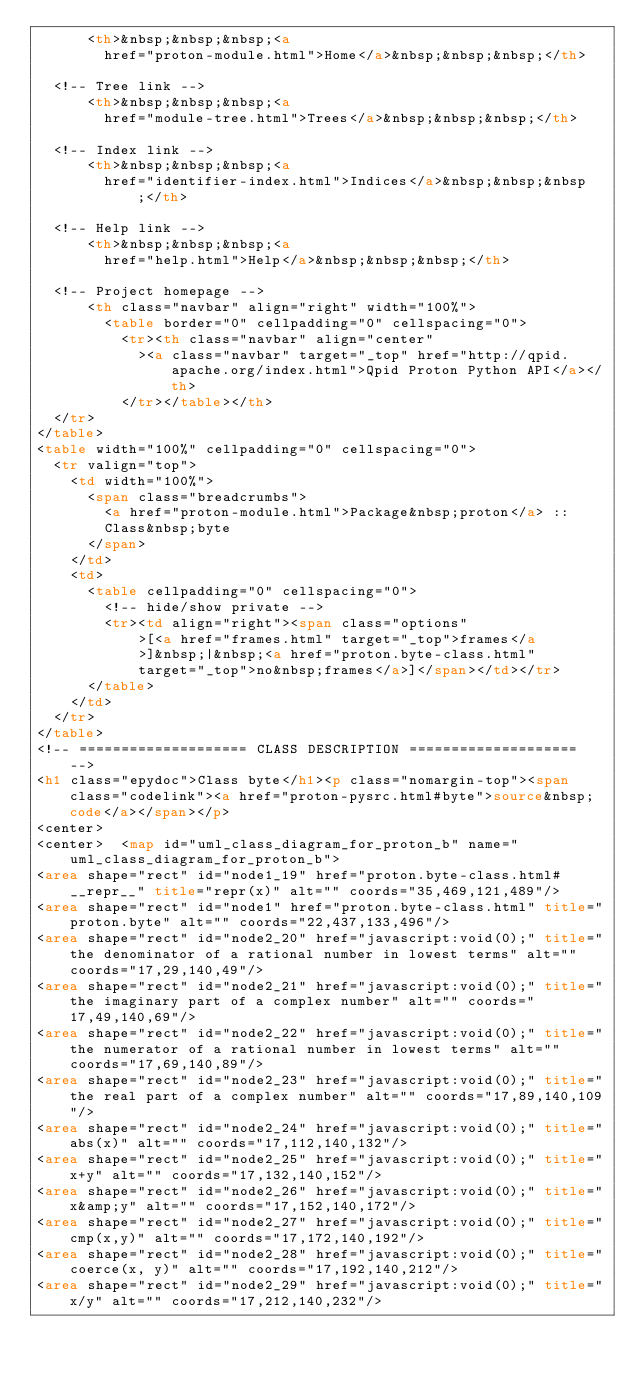Convert code to text. <code><loc_0><loc_0><loc_500><loc_500><_HTML_>      <th>&nbsp;&nbsp;&nbsp;<a
        href="proton-module.html">Home</a>&nbsp;&nbsp;&nbsp;</th>

  <!-- Tree link -->
      <th>&nbsp;&nbsp;&nbsp;<a
        href="module-tree.html">Trees</a>&nbsp;&nbsp;&nbsp;</th>

  <!-- Index link -->
      <th>&nbsp;&nbsp;&nbsp;<a
        href="identifier-index.html">Indices</a>&nbsp;&nbsp;&nbsp;</th>

  <!-- Help link -->
      <th>&nbsp;&nbsp;&nbsp;<a
        href="help.html">Help</a>&nbsp;&nbsp;&nbsp;</th>

  <!-- Project homepage -->
      <th class="navbar" align="right" width="100%">
        <table border="0" cellpadding="0" cellspacing="0">
          <tr><th class="navbar" align="center"
            ><a class="navbar" target="_top" href="http://qpid.apache.org/index.html">Qpid Proton Python API</a></th>
          </tr></table></th>
  </tr>
</table>
<table width="100%" cellpadding="0" cellspacing="0">
  <tr valign="top">
    <td width="100%">
      <span class="breadcrumbs">
        <a href="proton-module.html">Package&nbsp;proton</a> ::
        Class&nbsp;byte
      </span>
    </td>
    <td>
      <table cellpadding="0" cellspacing="0">
        <!-- hide/show private -->
        <tr><td align="right"><span class="options"
            >[<a href="frames.html" target="_top">frames</a
            >]&nbsp;|&nbsp;<a href="proton.byte-class.html"
            target="_top">no&nbsp;frames</a>]</span></td></tr>
      </table>
    </td>
  </tr>
</table>
<!-- ==================== CLASS DESCRIPTION ==================== -->
<h1 class="epydoc">Class byte</h1><p class="nomargin-top"><span class="codelink"><a href="proton-pysrc.html#byte">source&nbsp;code</a></span></p>
<center>
<center>  <map id="uml_class_diagram_for_proton_b" name="uml_class_diagram_for_proton_b">
<area shape="rect" id="node1_19" href="proton.byte-class.html#__repr__" title="repr(x)" alt="" coords="35,469,121,489"/>
<area shape="rect" id="node1" href="proton.byte-class.html" title="proton.byte" alt="" coords="22,437,133,496"/>
<area shape="rect" id="node2_20" href="javascript:void(0);" title="the denominator of a rational number in lowest terms" alt="" coords="17,29,140,49"/>
<area shape="rect" id="node2_21" href="javascript:void(0);" title="the imaginary part of a complex number" alt="" coords="17,49,140,69"/>
<area shape="rect" id="node2_22" href="javascript:void(0);" title="the numerator of a rational number in lowest terms" alt="" coords="17,69,140,89"/>
<area shape="rect" id="node2_23" href="javascript:void(0);" title="the real part of a complex number" alt="" coords="17,89,140,109"/>
<area shape="rect" id="node2_24" href="javascript:void(0);" title="abs(x)" alt="" coords="17,112,140,132"/>
<area shape="rect" id="node2_25" href="javascript:void(0);" title="x+y" alt="" coords="17,132,140,152"/>
<area shape="rect" id="node2_26" href="javascript:void(0);" title="x&amp;y" alt="" coords="17,152,140,172"/>
<area shape="rect" id="node2_27" href="javascript:void(0);" title="cmp(x,y)" alt="" coords="17,172,140,192"/>
<area shape="rect" id="node2_28" href="javascript:void(0);" title="coerce(x, y)" alt="" coords="17,192,140,212"/>
<area shape="rect" id="node2_29" href="javascript:void(0);" title="x/y" alt="" coords="17,212,140,232"/></code> 